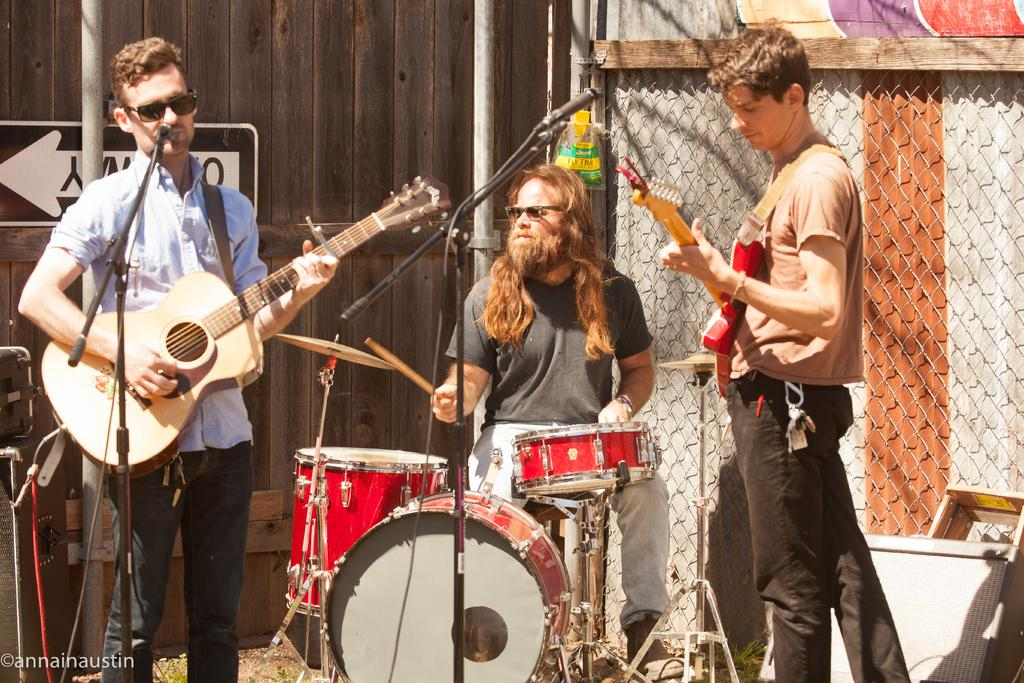How many people are in the image? There are three persons in the image. What are two of the persons doing? Two of the persons are playing guitars. What is the third person doing? The third person is playing drums. Can you describe any background elements in the image? There is a pole in the background of the image. What type of winter offer can be seen on the pole in the image? There is no winter offer or pole with any offer present in the image. 